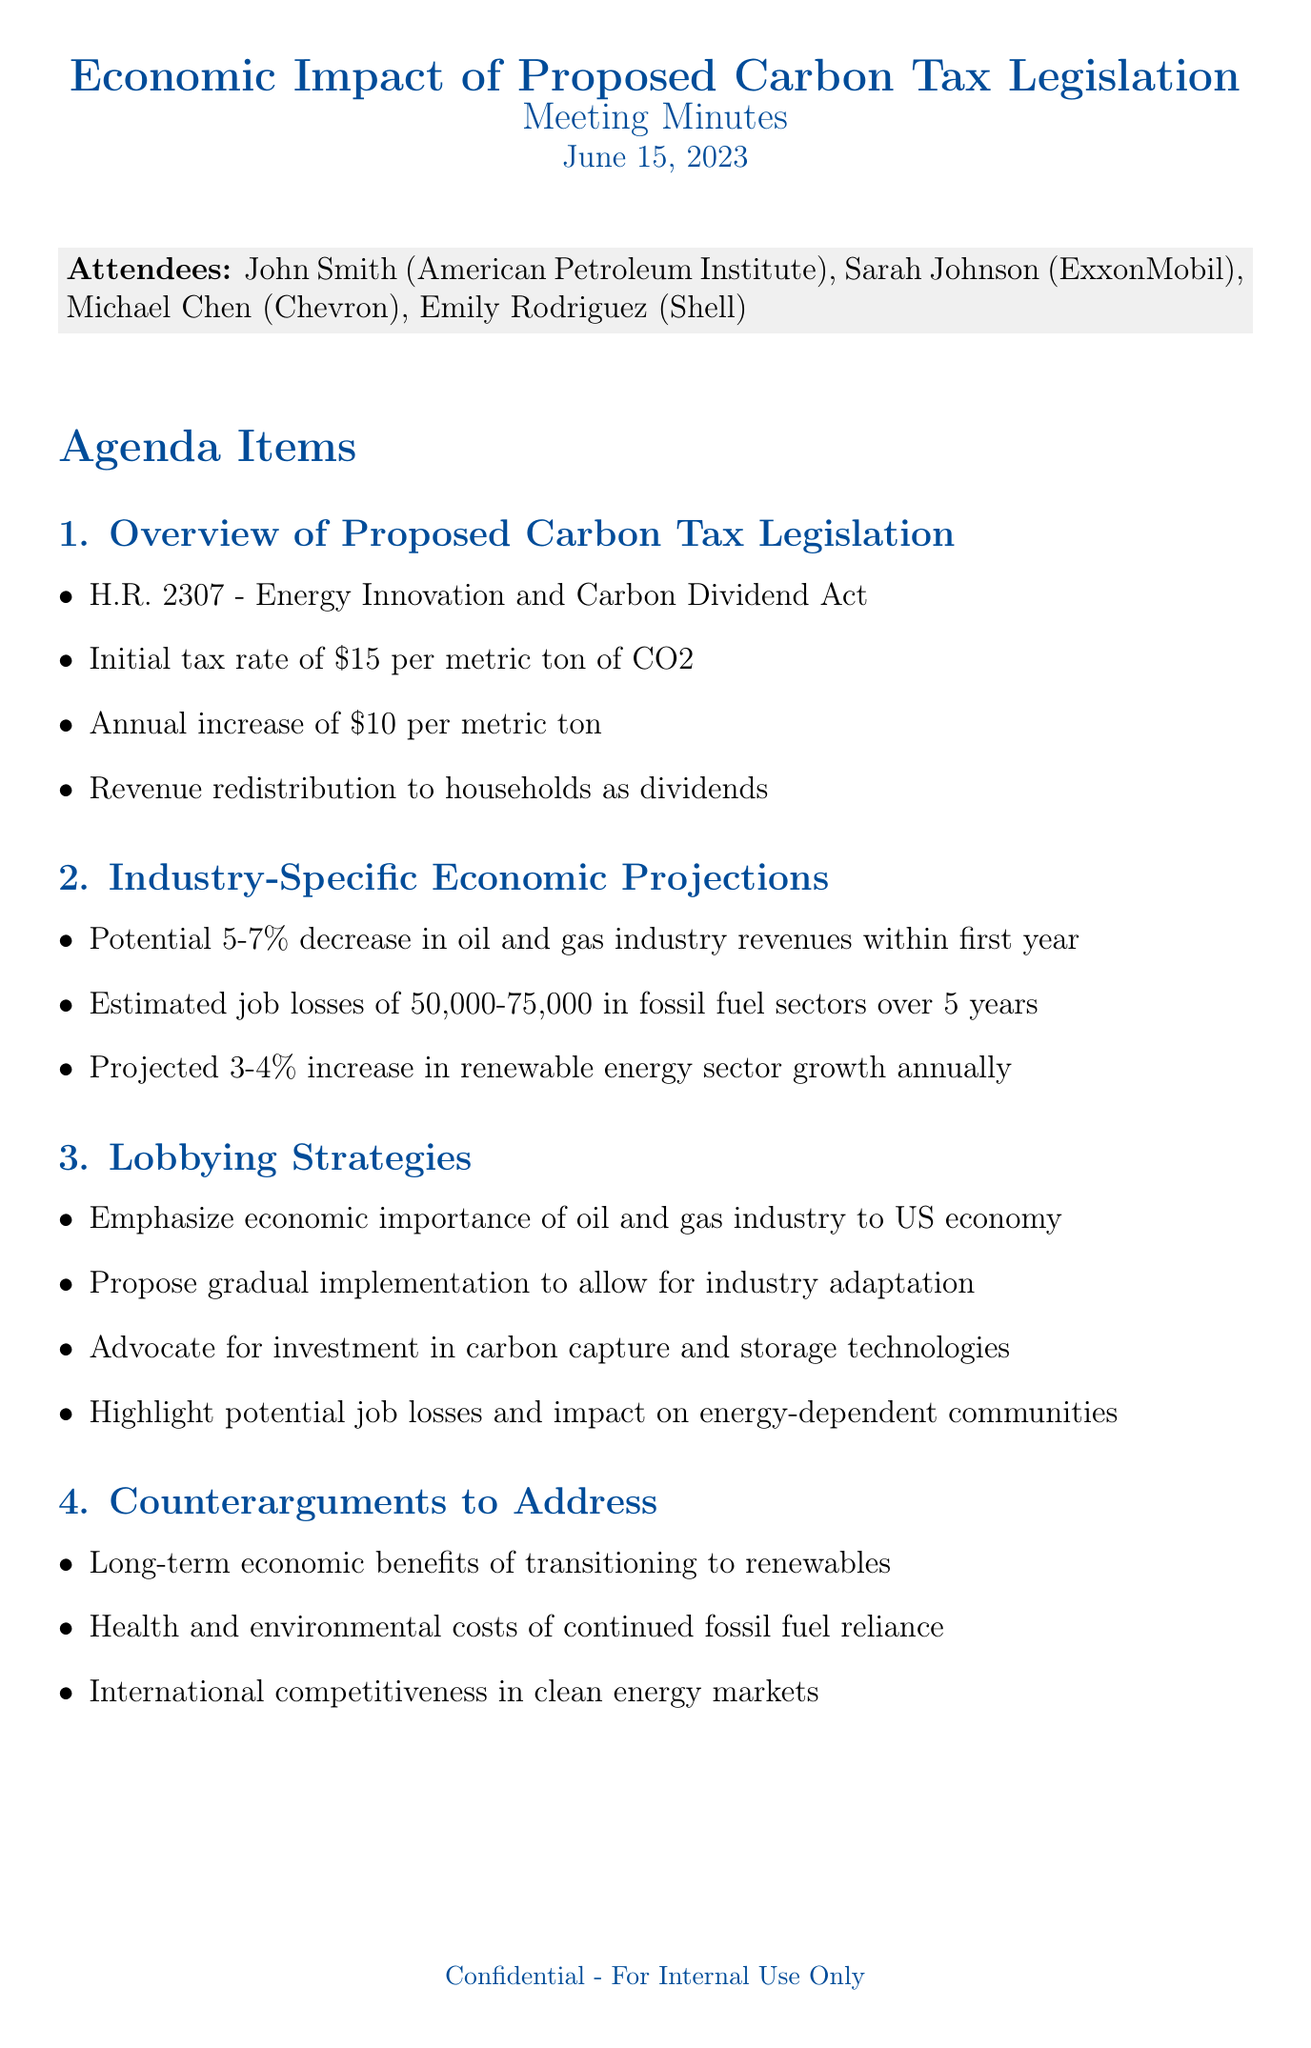What is the proposed carbon tax rate? The initial tax rate is stated as part of the proposed legislation.
Answer: $15 per metric ton How much is the annual increase for the carbon tax? The document mentions the increase in the tax rate each year.
Answer: $10 per metric ton What is the projected annual growth rate of the renewable energy sector? The growth rate is indicated in economic projections for the renewable sector.
Answer: 3-4% How many attendees were present at the meeting? The attendees list is provided in the document.
Answer: 4 What is the estimated number of job losses in fossil fuel sectors over 5 years? The document provides a specific range for job losses in the industry.
Answer: 50,000-75,000 What action item involves the Senate Energy Committee? The actions to be taken post-meeting include reporting to various entities.
Answer: Prepare economic impact report What lobbying strategy emphasizes gradual changes? The strategies include various approaches to the proposed tax legislation's implementation.
Answer: Propose gradual implementation What counterargument addresses health costs? The document lists counterarguments that favor renewable energy.
Answer: Health and environmental costs of continued fossil fuel reliance Which company does Sarah Johnson represent? The attendees list provides affiliations for each person present.
Answer: ExxonMobil 